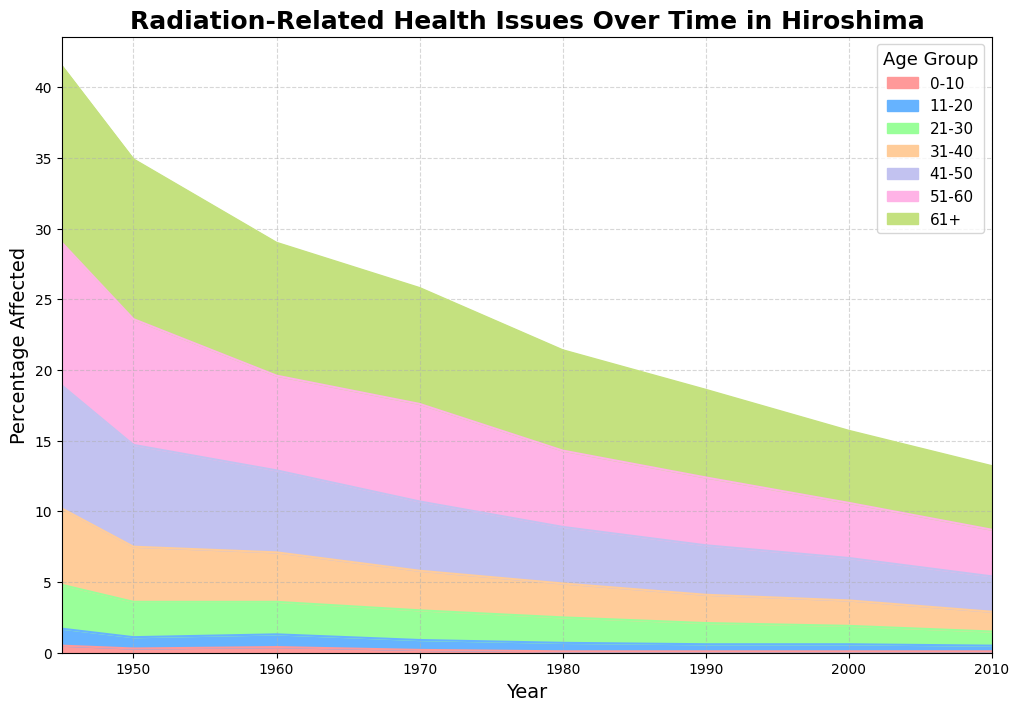1. How has the percentage of cancer-affected individuals aged 61+ changed from 1945 to 2010? To find this, look at the area for the age group 61+ in 1945 and then in 2010. In 1945, it was 12.5%, and in 2010, it is 4.5%. This means it decreased by 8%.
Answer: It decreased by 8% 2. Which age group had the highest percentage of cancer-affected individuals in 1960? To answer this, identify the age group with the highest area in 1960. From the chart, the age group 61+ had the highest percentage of 9.4%.
Answer: 61+ 3. Compare the trend in cancer percentages between age groups 0-10 and 51-60 from 1945 to 2010. Analyze both age groups in the chart. For 0-10, percentages decreased from 0.5% to 0.1%. For 51-60, the percentage decreased from 10.1% to 3.3%. Therefore, both groups saw a decrease, but the 51-60 group had a more significant absolute decrease.
Answer: Both decreased, 51-60 had a more significant decrease 4. What is the difference in the percentage of cancer-affected individuals between the age groups 31-40 and 21-30 in 1970? Look at the chart for the year 1970. For 31-40, it was 2.8%, and for 21-30, it was 2.1%. The difference is 2.8% - 2.1% = 0.7%.
Answer: 0.7% 5. During which year was the percentage of cancer-affected individuals the lowest for the age group 41-50, and what was that percentage? Check the chart for the lowest point in air area representing 41-50. In 1980, it was the lowest at 4.0%.
Answer: 1980, 4.0% 6. If you were to sum the percentages for the age groups 11-20 and 21-30 in the year 2000, what would it be? In 2000, the percentage for 11-20 is 0.5% and for 21-30 is 1.3%. Adding them gives 0.5% + 1.3% = 1.8%.
Answer: 1.8% 7. By what factor did the percentage of cancer-affected individuals in the age group 51-60 decrease between 1945 and 2010? In 1945, the percentage was 10.1%, and in 2010 it was 3.3%. The factor is 10.1 / 3.3 = ~3.06.
Answer: ~3.06 8. What is the average cancer percentage for the age group 31-40 from 1945 to 2010? Average = (5.4 + 3.9 + 3.5 + 2.8 + 2.4 + 2.0 + 1.8 + 1.4) / 8 = 2.9%.
Answer: 2.9% 9. In which decade did the most significant decrease in cancer percentage occur for the age group 0-10? Compare the percentages for each decade. The most significant decrease is from 1945 (0.5%) to 1950 (0.3%) = 0.2%.
Answer: 1945 to 1950 10. Describe the visual difference in the colors representing the age group 11-20 and 51-60. The color representing 11-20 is light blue, and the color for 51-60 is light purple.
Answer: Light blue and light purple 